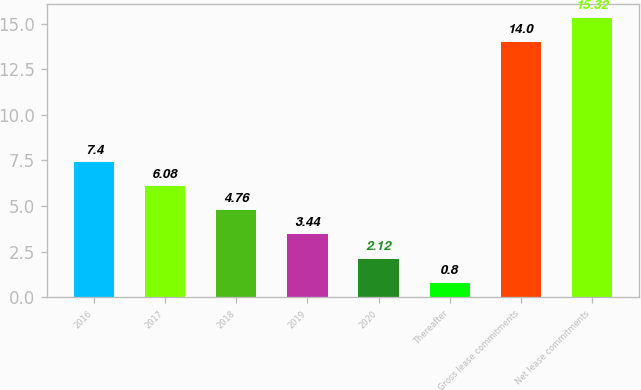Convert chart. <chart><loc_0><loc_0><loc_500><loc_500><bar_chart><fcel>2016<fcel>2017<fcel>2018<fcel>2019<fcel>2020<fcel>Thereafter<fcel>Gross lease commitments<fcel>Net lease commitments<nl><fcel>7.4<fcel>6.08<fcel>4.76<fcel>3.44<fcel>2.12<fcel>0.8<fcel>14<fcel>15.32<nl></chart> 